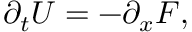<formula> <loc_0><loc_0><loc_500><loc_500>\partial _ { t } U = - \partial _ { x } F ,</formula> 